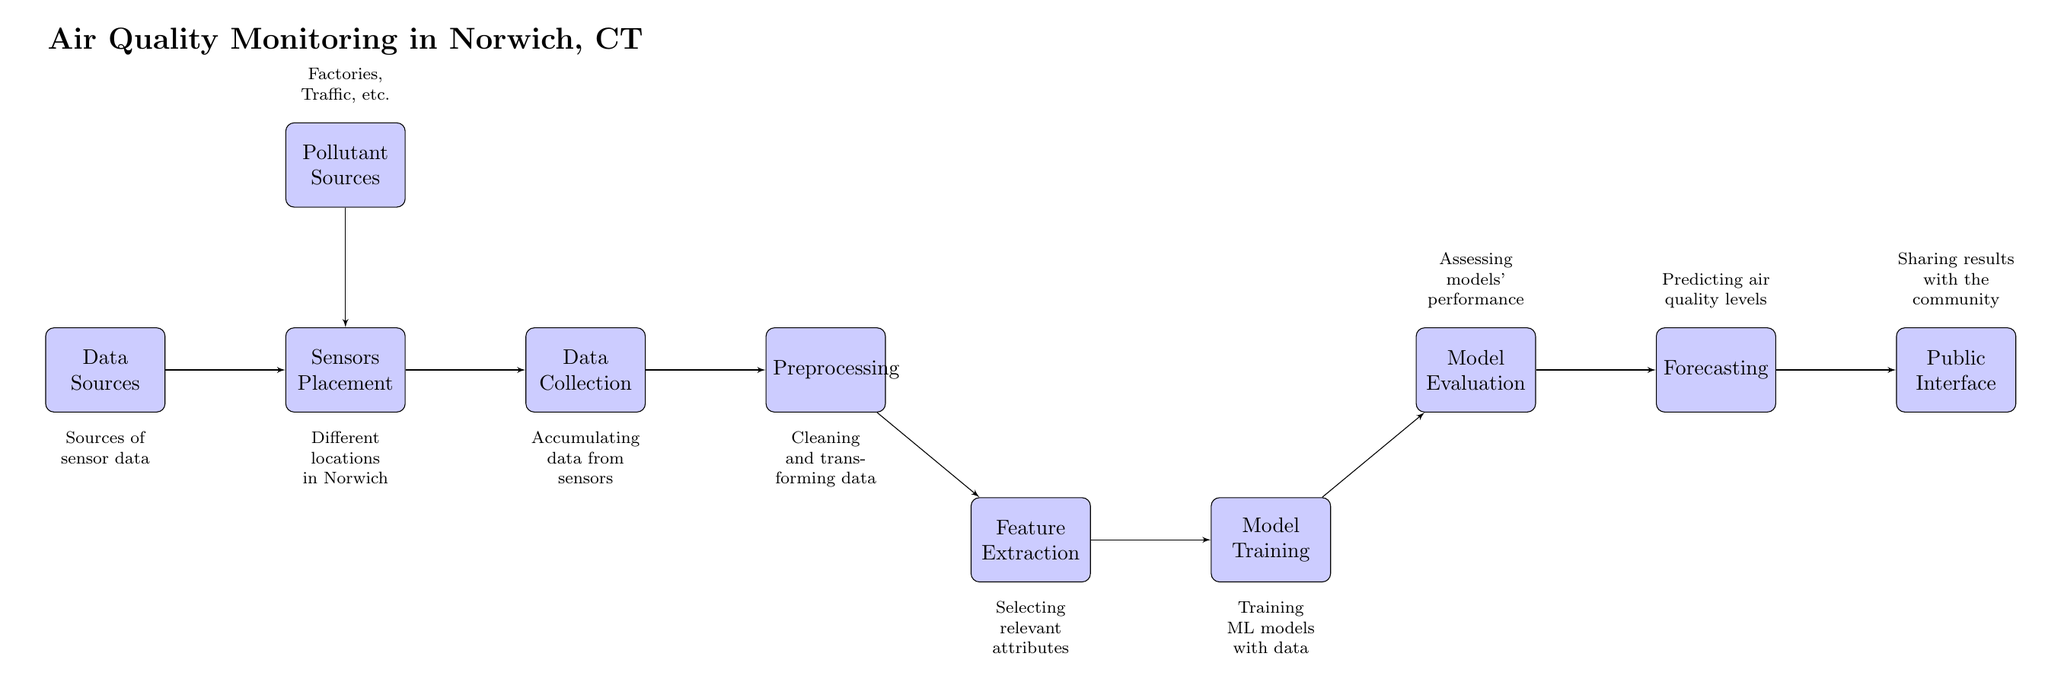What are the data sources for this diagram? The diagram identifies "Data Sources" as the starting point. It does not list specific data sources; it generally refers to "Sources of sensor data."
Answer: Sources of sensor data How many blocks are there in the diagram? By visually counting the blocks in the diagram, we can see 8 distinct blocks representing different stages in the process.
Answer: 8 What is the next step after preprocessing? The workflow indicates that after the "Preprocessing" block, the next step is "Feature Extraction." This shows a direct connection from one block to the next in the diagram order.
Answer: Feature Extraction Which block shares its output with the public interface? The "Forecasting" block feeds its results into the "Public Interface" block. This implies that on the diagram, the forecasting results are made available to the community.
Answer: Forecasting Where do pollutant sources fit into this monitoring process? The "Pollutant Sources" block is positioned above the "Sensors Placement" block, indicating that the data about pollutant sources informs where sensors are placed for air quality monitoring.
Answer: Sensors Placement What happens during model training? The "Model Training" block indicates that machine learning models are trained using the relevant data. This is a critical step for creating effective models for predicting air quality.
Answer: Training ML models with data What comes before model evaluation? The flow of the diagram shows that "Model Training" must be completed before reaching the "Model Evaluation" stage, highlighting this sequential relationship.
Answer: Model Training What is the purpose of the public interface? The "Public Interface" block represents the final step where results are shared with the community, allowing the local population to access information about air quality.
Answer: Sharing results with the community 